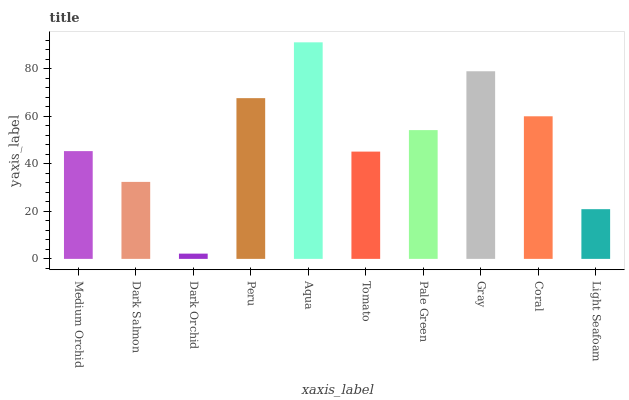Is Dark Orchid the minimum?
Answer yes or no. Yes. Is Aqua the maximum?
Answer yes or no. Yes. Is Dark Salmon the minimum?
Answer yes or no. No. Is Dark Salmon the maximum?
Answer yes or no. No. Is Medium Orchid greater than Dark Salmon?
Answer yes or no. Yes. Is Dark Salmon less than Medium Orchid?
Answer yes or no. Yes. Is Dark Salmon greater than Medium Orchid?
Answer yes or no. No. Is Medium Orchid less than Dark Salmon?
Answer yes or no. No. Is Pale Green the high median?
Answer yes or no. Yes. Is Medium Orchid the low median?
Answer yes or no. Yes. Is Peru the high median?
Answer yes or no. No. Is Pale Green the low median?
Answer yes or no. No. 